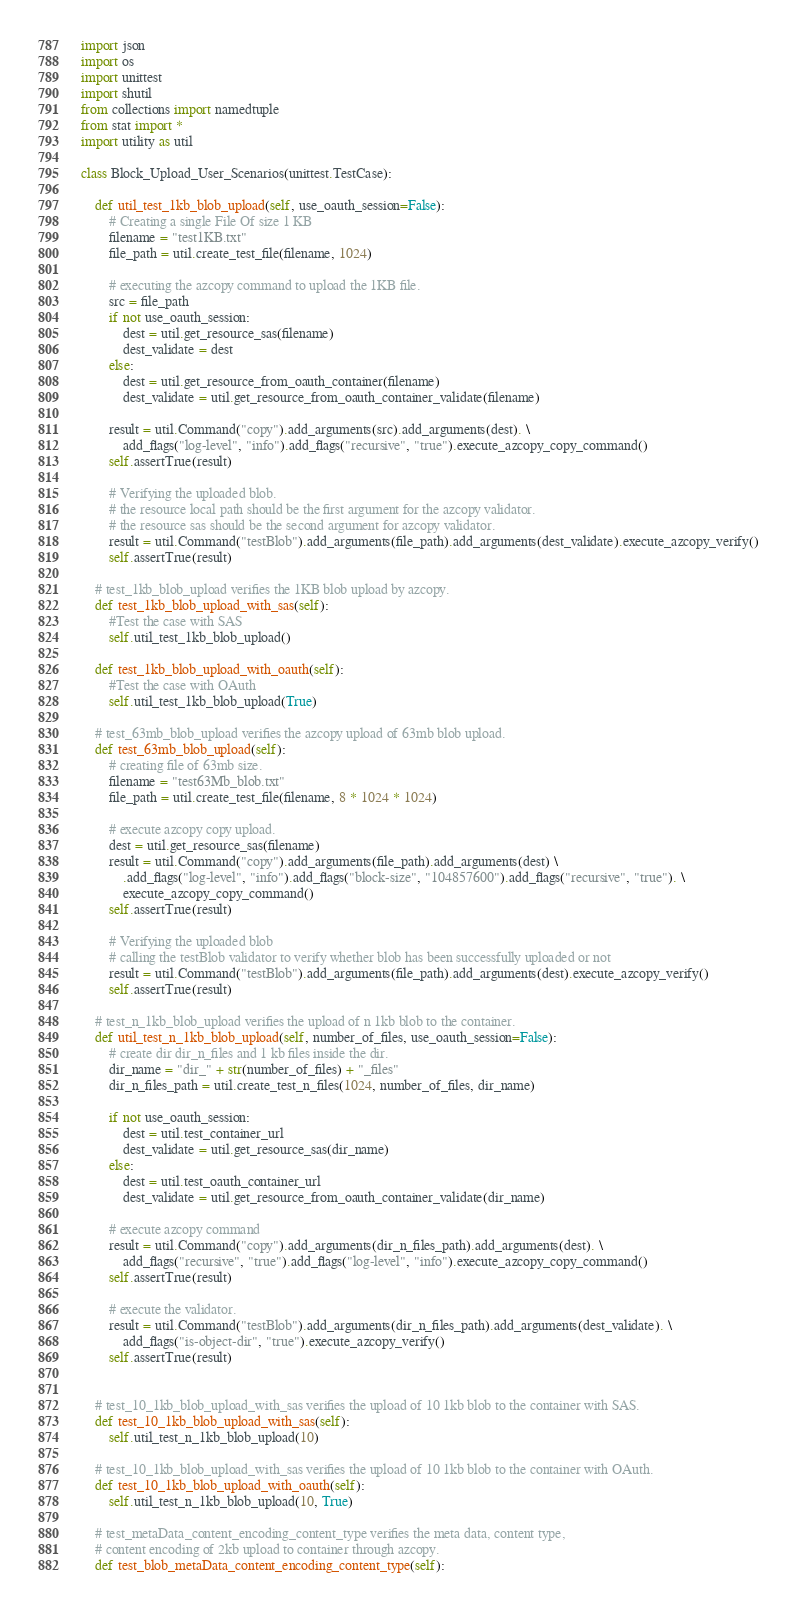Convert code to text. <code><loc_0><loc_0><loc_500><loc_500><_Python_>import json
import os
import unittest
import shutil
from collections import namedtuple
from stat import *
import utility as util

class Block_Upload_User_Scenarios(unittest.TestCase):

    def util_test_1kb_blob_upload(self, use_oauth_session=False):
        # Creating a single File Of size 1 KB
        filename = "test1KB.txt"
        file_path = util.create_test_file(filename, 1024)

        # executing the azcopy command to upload the 1KB file.
        src = file_path
        if not use_oauth_session:
            dest = util.get_resource_sas(filename)
            dest_validate = dest
        else:
            dest = util.get_resource_from_oauth_container(filename)
            dest_validate = util.get_resource_from_oauth_container_validate(filename)

        result = util.Command("copy").add_arguments(src).add_arguments(dest). \
            add_flags("log-level", "info").add_flags("recursive", "true").execute_azcopy_copy_command()
        self.assertTrue(result)

        # Verifying the uploaded blob.
        # the resource local path should be the first argument for the azcopy validator.
        # the resource sas should be the second argument for azcopy validator.
        result = util.Command("testBlob").add_arguments(file_path).add_arguments(dest_validate).execute_azcopy_verify()
        self.assertTrue(result)

    # test_1kb_blob_upload verifies the 1KB blob upload by azcopy.
    def test_1kb_blob_upload_with_sas(self):
        #Test the case with SAS
        self.util_test_1kb_blob_upload()

    def test_1kb_blob_upload_with_oauth(self):
        #Test the case with OAuth
        self.util_test_1kb_blob_upload(True)

    # test_63mb_blob_upload verifies the azcopy upload of 63mb blob upload.
    def test_63mb_blob_upload(self):
        # creating file of 63mb size.
        filename = "test63Mb_blob.txt"
        file_path = util.create_test_file(filename, 8 * 1024 * 1024)

        # execute azcopy copy upload.
        dest = util.get_resource_sas(filename)
        result = util.Command("copy").add_arguments(file_path).add_arguments(dest) \
            .add_flags("log-level", "info").add_flags("block-size", "104857600").add_flags("recursive", "true"). \
            execute_azcopy_copy_command()
        self.assertTrue(result)

        # Verifying the uploaded blob
        # calling the testBlob validator to verify whether blob has been successfully uploaded or not
        result = util.Command("testBlob").add_arguments(file_path).add_arguments(dest).execute_azcopy_verify()
        self.assertTrue(result)

    # test_n_1kb_blob_upload verifies the upload of n 1kb blob to the container.
    def util_test_n_1kb_blob_upload(self, number_of_files, use_oauth_session=False):
        # create dir dir_n_files and 1 kb files inside the dir.
        dir_name = "dir_" + str(number_of_files) + "_files"
        dir_n_files_path = util.create_test_n_files(1024, number_of_files, dir_name)

        if not use_oauth_session:
            dest = util.test_container_url
            dest_validate = util.get_resource_sas(dir_name)
        else:
            dest = util.test_oauth_container_url
            dest_validate = util.get_resource_from_oauth_container_validate(dir_name)

        # execute azcopy command
        result = util.Command("copy").add_arguments(dir_n_files_path).add_arguments(dest). \
            add_flags("recursive", "true").add_flags("log-level", "info").execute_azcopy_copy_command()
        self.assertTrue(result)

        # execute the validator.
        result = util.Command("testBlob").add_arguments(dir_n_files_path).add_arguments(dest_validate). \
            add_flags("is-object-dir", "true").execute_azcopy_verify()
        self.assertTrue(result)


    # test_10_1kb_blob_upload_with_sas verifies the upload of 10 1kb blob to the container with SAS.
    def test_10_1kb_blob_upload_with_sas(self):
        self.util_test_n_1kb_blob_upload(10)

    # test_10_1kb_blob_upload_with_sas verifies the upload of 10 1kb blob to the container with OAuth.
    def test_10_1kb_blob_upload_with_oauth(self):
        self.util_test_n_1kb_blob_upload(10, True)

    # test_metaData_content_encoding_content_type verifies the meta data, content type,
    # content encoding of 2kb upload to container through azcopy.
    def test_blob_metaData_content_encoding_content_type(self):</code> 